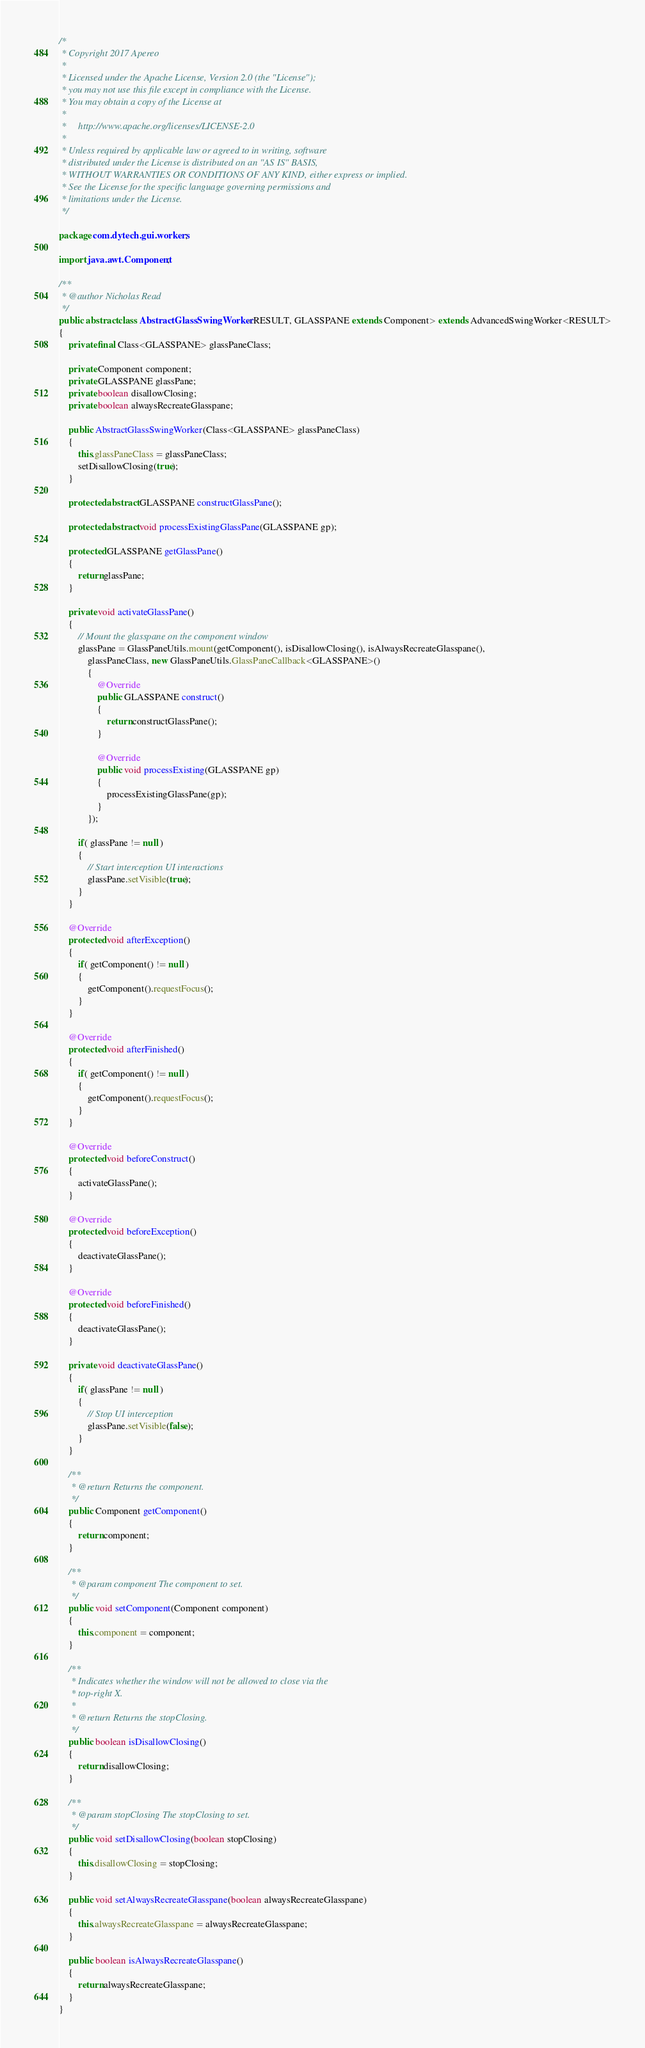<code> <loc_0><loc_0><loc_500><loc_500><_Java_>/*
 * Copyright 2017 Apereo
 *
 * Licensed under the Apache License, Version 2.0 (the "License");
 * you may not use this file except in compliance with the License.
 * You may obtain a copy of the License at
 *
 *     http://www.apache.org/licenses/LICENSE-2.0
 *
 * Unless required by applicable law or agreed to in writing, software
 * distributed under the License is distributed on an "AS IS" BASIS,
 * WITHOUT WARRANTIES OR CONDITIONS OF ANY KIND, either express or implied.
 * See the License for the specific language governing permissions and
 * limitations under the License.
 */

package com.dytech.gui.workers;

import java.awt.Component;

/**
 * @author Nicholas Read
 */
public abstract class AbstractGlassSwingWorker<RESULT, GLASSPANE extends Component> extends AdvancedSwingWorker<RESULT>
{
	private final Class<GLASSPANE> glassPaneClass;

	private Component component;
	private GLASSPANE glassPane;
	private boolean disallowClosing;
	private boolean alwaysRecreateGlasspane;

	public AbstractGlassSwingWorker(Class<GLASSPANE> glassPaneClass)
	{
		this.glassPaneClass = glassPaneClass;
		setDisallowClosing(true);
	}

	protected abstract GLASSPANE constructGlassPane();

	protected abstract void processExistingGlassPane(GLASSPANE gp);

	protected GLASSPANE getGlassPane()
	{
		return glassPane;
	}

	private void activateGlassPane()
	{
		// Mount the glasspane on the component window
		glassPane = GlassPaneUtils.mount(getComponent(), isDisallowClosing(), isAlwaysRecreateGlasspane(),
			glassPaneClass, new GlassPaneUtils.GlassPaneCallback<GLASSPANE>()
			{
				@Override
				public GLASSPANE construct()
				{
					return constructGlassPane();
				}

				@Override
				public void processExisting(GLASSPANE gp)
				{
					processExistingGlassPane(gp);
				}
			});

		if( glassPane != null )
		{
			// Start interception UI interactions
			glassPane.setVisible(true);
		}
	}

	@Override
	protected void afterException()
	{
		if( getComponent() != null )
		{
			getComponent().requestFocus();
		}
	}

	@Override
	protected void afterFinished()
	{
		if( getComponent() != null )
		{
			getComponent().requestFocus();
		}
	}

	@Override
	protected void beforeConstruct()
	{
		activateGlassPane();
	}

	@Override
	protected void beforeException()
	{
		deactivateGlassPane();
	}

	@Override
	protected void beforeFinished()
	{
		deactivateGlassPane();
	}

	private void deactivateGlassPane()
	{
		if( glassPane != null )
		{
			// Stop UI interception
			glassPane.setVisible(false);
		}
	}

	/**
	 * @return Returns the component.
	 */
	public Component getComponent()
	{
		return component;
	}

	/**
	 * @param component The component to set.
	 */
	public void setComponent(Component component)
	{
		this.component = component;
	}

	/**
	 * Indicates whether the window will not be allowed to close via the
	 * top-right X.
	 * 
	 * @return Returns the stopClosing.
	 */
	public boolean isDisallowClosing()
	{
		return disallowClosing;
	}

	/**
	 * @param stopClosing The stopClosing to set.
	 */
	public void setDisallowClosing(boolean stopClosing)
	{
		this.disallowClosing = stopClosing;
	}

	public void setAlwaysRecreateGlasspane(boolean alwaysRecreateGlasspane)
	{
		this.alwaysRecreateGlasspane = alwaysRecreateGlasspane;
	}

	public boolean isAlwaysRecreateGlasspane()
	{
		return alwaysRecreateGlasspane;
	}
}</code> 